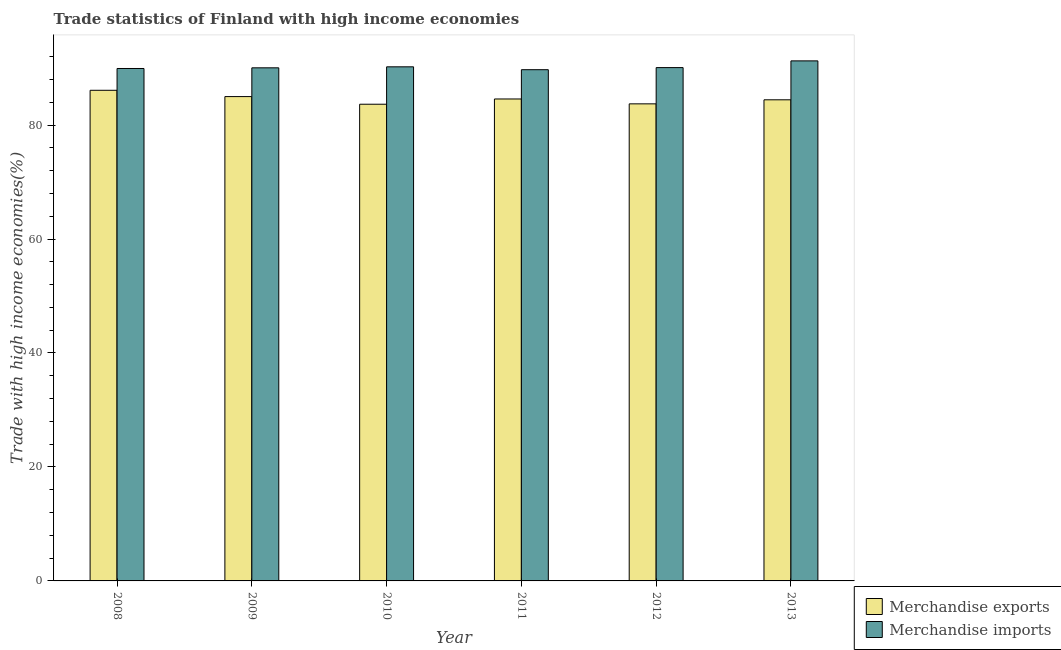Are the number of bars per tick equal to the number of legend labels?
Make the answer very short. Yes. How many bars are there on the 2nd tick from the left?
Your answer should be compact. 2. How many bars are there on the 3rd tick from the right?
Offer a terse response. 2. What is the label of the 1st group of bars from the left?
Keep it short and to the point. 2008. In how many cases, is the number of bars for a given year not equal to the number of legend labels?
Ensure brevity in your answer.  0. What is the merchandise exports in 2012?
Provide a short and direct response. 83.72. Across all years, what is the maximum merchandise exports?
Keep it short and to the point. 86.1. Across all years, what is the minimum merchandise exports?
Ensure brevity in your answer.  83.65. In which year was the merchandise imports minimum?
Your response must be concise. 2011. What is the total merchandise imports in the graph?
Give a very brief answer. 541.23. What is the difference between the merchandise exports in 2008 and that in 2011?
Give a very brief answer. 1.52. What is the difference between the merchandise exports in 2013 and the merchandise imports in 2011?
Provide a short and direct response. -0.15. What is the average merchandise imports per year?
Give a very brief answer. 90.2. In the year 2013, what is the difference between the merchandise imports and merchandise exports?
Provide a short and direct response. 0. In how many years, is the merchandise imports greater than 84 %?
Make the answer very short. 6. What is the ratio of the merchandise imports in 2009 to that in 2011?
Give a very brief answer. 1. What is the difference between the highest and the second highest merchandise imports?
Offer a very short reply. 1.04. What is the difference between the highest and the lowest merchandise exports?
Make the answer very short. 2.44. In how many years, is the merchandise imports greater than the average merchandise imports taken over all years?
Offer a terse response. 2. What does the 1st bar from the left in 2009 represents?
Offer a terse response. Merchandise exports. Are all the bars in the graph horizontal?
Offer a terse response. No. What is the difference between two consecutive major ticks on the Y-axis?
Offer a terse response. 20. Does the graph contain grids?
Provide a succinct answer. No. How many legend labels are there?
Make the answer very short. 2. How are the legend labels stacked?
Provide a short and direct response. Vertical. What is the title of the graph?
Your response must be concise. Trade statistics of Finland with high income economies. What is the label or title of the Y-axis?
Keep it short and to the point. Trade with high income economies(%). What is the Trade with high income economies(%) of Merchandise exports in 2008?
Give a very brief answer. 86.1. What is the Trade with high income economies(%) of Merchandise imports in 2008?
Offer a terse response. 89.92. What is the Trade with high income economies(%) in Merchandise exports in 2009?
Your answer should be very brief. 84.99. What is the Trade with high income economies(%) of Merchandise imports in 2009?
Make the answer very short. 90.04. What is the Trade with high income economies(%) of Merchandise exports in 2010?
Your response must be concise. 83.65. What is the Trade with high income economies(%) in Merchandise imports in 2010?
Keep it short and to the point. 90.21. What is the Trade with high income economies(%) of Merchandise exports in 2011?
Your answer should be compact. 84.57. What is the Trade with high income economies(%) of Merchandise imports in 2011?
Your answer should be compact. 89.71. What is the Trade with high income economies(%) in Merchandise exports in 2012?
Give a very brief answer. 83.72. What is the Trade with high income economies(%) of Merchandise imports in 2012?
Keep it short and to the point. 90.08. What is the Trade with high income economies(%) of Merchandise exports in 2013?
Keep it short and to the point. 84.43. What is the Trade with high income economies(%) of Merchandise imports in 2013?
Provide a succinct answer. 91.26. Across all years, what is the maximum Trade with high income economies(%) of Merchandise exports?
Your answer should be very brief. 86.1. Across all years, what is the maximum Trade with high income economies(%) of Merchandise imports?
Your response must be concise. 91.26. Across all years, what is the minimum Trade with high income economies(%) of Merchandise exports?
Give a very brief answer. 83.65. Across all years, what is the minimum Trade with high income economies(%) in Merchandise imports?
Your answer should be very brief. 89.71. What is the total Trade with high income economies(%) of Merchandise exports in the graph?
Keep it short and to the point. 507.46. What is the total Trade with high income economies(%) in Merchandise imports in the graph?
Keep it short and to the point. 541.23. What is the difference between the Trade with high income economies(%) in Merchandise exports in 2008 and that in 2009?
Your response must be concise. 1.1. What is the difference between the Trade with high income economies(%) of Merchandise imports in 2008 and that in 2009?
Provide a succinct answer. -0.12. What is the difference between the Trade with high income economies(%) in Merchandise exports in 2008 and that in 2010?
Offer a terse response. 2.44. What is the difference between the Trade with high income economies(%) of Merchandise imports in 2008 and that in 2010?
Your answer should be very brief. -0.29. What is the difference between the Trade with high income economies(%) in Merchandise exports in 2008 and that in 2011?
Offer a terse response. 1.52. What is the difference between the Trade with high income economies(%) in Merchandise imports in 2008 and that in 2011?
Your answer should be compact. 0.21. What is the difference between the Trade with high income economies(%) in Merchandise exports in 2008 and that in 2012?
Your answer should be compact. 2.38. What is the difference between the Trade with high income economies(%) of Merchandise imports in 2008 and that in 2012?
Offer a terse response. -0.16. What is the difference between the Trade with high income economies(%) of Merchandise exports in 2008 and that in 2013?
Offer a terse response. 1.67. What is the difference between the Trade with high income economies(%) of Merchandise imports in 2008 and that in 2013?
Provide a short and direct response. -1.34. What is the difference between the Trade with high income economies(%) of Merchandise exports in 2009 and that in 2010?
Ensure brevity in your answer.  1.34. What is the difference between the Trade with high income economies(%) in Merchandise imports in 2009 and that in 2010?
Keep it short and to the point. -0.17. What is the difference between the Trade with high income economies(%) in Merchandise exports in 2009 and that in 2011?
Keep it short and to the point. 0.42. What is the difference between the Trade with high income economies(%) in Merchandise imports in 2009 and that in 2011?
Your response must be concise. 0.33. What is the difference between the Trade with high income economies(%) in Merchandise exports in 2009 and that in 2012?
Make the answer very short. 1.27. What is the difference between the Trade with high income economies(%) of Merchandise imports in 2009 and that in 2012?
Your answer should be compact. -0.04. What is the difference between the Trade with high income economies(%) of Merchandise exports in 2009 and that in 2013?
Offer a terse response. 0.56. What is the difference between the Trade with high income economies(%) of Merchandise imports in 2009 and that in 2013?
Offer a terse response. -1.22. What is the difference between the Trade with high income economies(%) in Merchandise exports in 2010 and that in 2011?
Your answer should be compact. -0.92. What is the difference between the Trade with high income economies(%) in Merchandise imports in 2010 and that in 2011?
Provide a succinct answer. 0.5. What is the difference between the Trade with high income economies(%) in Merchandise exports in 2010 and that in 2012?
Ensure brevity in your answer.  -0.07. What is the difference between the Trade with high income economies(%) in Merchandise imports in 2010 and that in 2012?
Keep it short and to the point. 0.13. What is the difference between the Trade with high income economies(%) in Merchandise exports in 2010 and that in 2013?
Make the answer very short. -0.77. What is the difference between the Trade with high income economies(%) of Merchandise imports in 2010 and that in 2013?
Keep it short and to the point. -1.04. What is the difference between the Trade with high income economies(%) of Merchandise exports in 2011 and that in 2012?
Give a very brief answer. 0.86. What is the difference between the Trade with high income economies(%) in Merchandise imports in 2011 and that in 2012?
Keep it short and to the point. -0.37. What is the difference between the Trade with high income economies(%) of Merchandise exports in 2011 and that in 2013?
Offer a terse response. 0.15. What is the difference between the Trade with high income economies(%) of Merchandise imports in 2011 and that in 2013?
Offer a terse response. -1.55. What is the difference between the Trade with high income economies(%) in Merchandise exports in 2012 and that in 2013?
Your answer should be very brief. -0.71. What is the difference between the Trade with high income economies(%) of Merchandise imports in 2012 and that in 2013?
Ensure brevity in your answer.  -1.18. What is the difference between the Trade with high income economies(%) of Merchandise exports in 2008 and the Trade with high income economies(%) of Merchandise imports in 2009?
Your answer should be very brief. -3.94. What is the difference between the Trade with high income economies(%) in Merchandise exports in 2008 and the Trade with high income economies(%) in Merchandise imports in 2010?
Make the answer very short. -4.12. What is the difference between the Trade with high income economies(%) in Merchandise exports in 2008 and the Trade with high income economies(%) in Merchandise imports in 2011?
Your response must be concise. -3.61. What is the difference between the Trade with high income economies(%) of Merchandise exports in 2008 and the Trade with high income economies(%) of Merchandise imports in 2012?
Offer a very short reply. -3.98. What is the difference between the Trade with high income economies(%) in Merchandise exports in 2008 and the Trade with high income economies(%) in Merchandise imports in 2013?
Ensure brevity in your answer.  -5.16. What is the difference between the Trade with high income economies(%) in Merchandise exports in 2009 and the Trade with high income economies(%) in Merchandise imports in 2010?
Your answer should be compact. -5.22. What is the difference between the Trade with high income economies(%) in Merchandise exports in 2009 and the Trade with high income economies(%) in Merchandise imports in 2011?
Provide a short and direct response. -4.72. What is the difference between the Trade with high income economies(%) in Merchandise exports in 2009 and the Trade with high income economies(%) in Merchandise imports in 2012?
Provide a short and direct response. -5.09. What is the difference between the Trade with high income economies(%) in Merchandise exports in 2009 and the Trade with high income economies(%) in Merchandise imports in 2013?
Keep it short and to the point. -6.27. What is the difference between the Trade with high income economies(%) of Merchandise exports in 2010 and the Trade with high income economies(%) of Merchandise imports in 2011?
Provide a succinct answer. -6.06. What is the difference between the Trade with high income economies(%) in Merchandise exports in 2010 and the Trade with high income economies(%) in Merchandise imports in 2012?
Offer a very short reply. -6.43. What is the difference between the Trade with high income economies(%) in Merchandise exports in 2010 and the Trade with high income economies(%) in Merchandise imports in 2013?
Give a very brief answer. -7.61. What is the difference between the Trade with high income economies(%) in Merchandise exports in 2011 and the Trade with high income economies(%) in Merchandise imports in 2012?
Your answer should be very brief. -5.51. What is the difference between the Trade with high income economies(%) of Merchandise exports in 2011 and the Trade with high income economies(%) of Merchandise imports in 2013?
Provide a short and direct response. -6.69. What is the difference between the Trade with high income economies(%) in Merchandise exports in 2012 and the Trade with high income economies(%) in Merchandise imports in 2013?
Provide a succinct answer. -7.54. What is the average Trade with high income economies(%) of Merchandise exports per year?
Your answer should be compact. 84.58. What is the average Trade with high income economies(%) in Merchandise imports per year?
Give a very brief answer. 90.2. In the year 2008, what is the difference between the Trade with high income economies(%) of Merchandise exports and Trade with high income economies(%) of Merchandise imports?
Provide a short and direct response. -3.83. In the year 2009, what is the difference between the Trade with high income economies(%) in Merchandise exports and Trade with high income economies(%) in Merchandise imports?
Give a very brief answer. -5.05. In the year 2010, what is the difference between the Trade with high income economies(%) of Merchandise exports and Trade with high income economies(%) of Merchandise imports?
Your response must be concise. -6.56. In the year 2011, what is the difference between the Trade with high income economies(%) in Merchandise exports and Trade with high income economies(%) in Merchandise imports?
Your answer should be compact. -5.14. In the year 2012, what is the difference between the Trade with high income economies(%) of Merchandise exports and Trade with high income economies(%) of Merchandise imports?
Your answer should be very brief. -6.36. In the year 2013, what is the difference between the Trade with high income economies(%) in Merchandise exports and Trade with high income economies(%) in Merchandise imports?
Your answer should be very brief. -6.83. What is the ratio of the Trade with high income economies(%) in Merchandise exports in 2008 to that in 2009?
Your response must be concise. 1.01. What is the ratio of the Trade with high income economies(%) in Merchandise exports in 2008 to that in 2010?
Ensure brevity in your answer.  1.03. What is the ratio of the Trade with high income economies(%) in Merchandise exports in 2008 to that in 2012?
Provide a short and direct response. 1.03. What is the ratio of the Trade with high income economies(%) in Merchandise imports in 2008 to that in 2012?
Offer a very short reply. 1. What is the ratio of the Trade with high income economies(%) of Merchandise exports in 2008 to that in 2013?
Your response must be concise. 1.02. What is the ratio of the Trade with high income economies(%) in Merchandise imports in 2008 to that in 2013?
Keep it short and to the point. 0.99. What is the ratio of the Trade with high income economies(%) in Merchandise exports in 2009 to that in 2010?
Provide a short and direct response. 1.02. What is the ratio of the Trade with high income economies(%) in Merchandise exports in 2009 to that in 2011?
Your answer should be very brief. 1. What is the ratio of the Trade with high income economies(%) in Merchandise imports in 2009 to that in 2011?
Ensure brevity in your answer.  1. What is the ratio of the Trade with high income economies(%) of Merchandise exports in 2009 to that in 2012?
Offer a very short reply. 1.02. What is the ratio of the Trade with high income economies(%) in Merchandise imports in 2009 to that in 2012?
Give a very brief answer. 1. What is the ratio of the Trade with high income economies(%) in Merchandise imports in 2009 to that in 2013?
Ensure brevity in your answer.  0.99. What is the ratio of the Trade with high income economies(%) in Merchandise imports in 2010 to that in 2011?
Your answer should be very brief. 1.01. What is the ratio of the Trade with high income economies(%) in Merchandise exports in 2010 to that in 2012?
Provide a succinct answer. 1. What is the ratio of the Trade with high income economies(%) of Merchandise imports in 2010 to that in 2012?
Ensure brevity in your answer.  1. What is the ratio of the Trade with high income economies(%) of Merchandise exports in 2010 to that in 2013?
Ensure brevity in your answer.  0.99. What is the ratio of the Trade with high income economies(%) in Merchandise exports in 2011 to that in 2012?
Your answer should be very brief. 1.01. What is the ratio of the Trade with high income economies(%) in Merchandise imports in 2011 to that in 2012?
Provide a short and direct response. 1. What is the ratio of the Trade with high income economies(%) in Merchandise exports in 2011 to that in 2013?
Give a very brief answer. 1. What is the ratio of the Trade with high income economies(%) in Merchandise imports in 2011 to that in 2013?
Offer a very short reply. 0.98. What is the ratio of the Trade with high income economies(%) of Merchandise exports in 2012 to that in 2013?
Give a very brief answer. 0.99. What is the ratio of the Trade with high income economies(%) of Merchandise imports in 2012 to that in 2013?
Ensure brevity in your answer.  0.99. What is the difference between the highest and the second highest Trade with high income economies(%) of Merchandise exports?
Offer a terse response. 1.1. What is the difference between the highest and the second highest Trade with high income economies(%) of Merchandise imports?
Give a very brief answer. 1.04. What is the difference between the highest and the lowest Trade with high income economies(%) of Merchandise exports?
Your answer should be very brief. 2.44. What is the difference between the highest and the lowest Trade with high income economies(%) of Merchandise imports?
Your answer should be very brief. 1.55. 